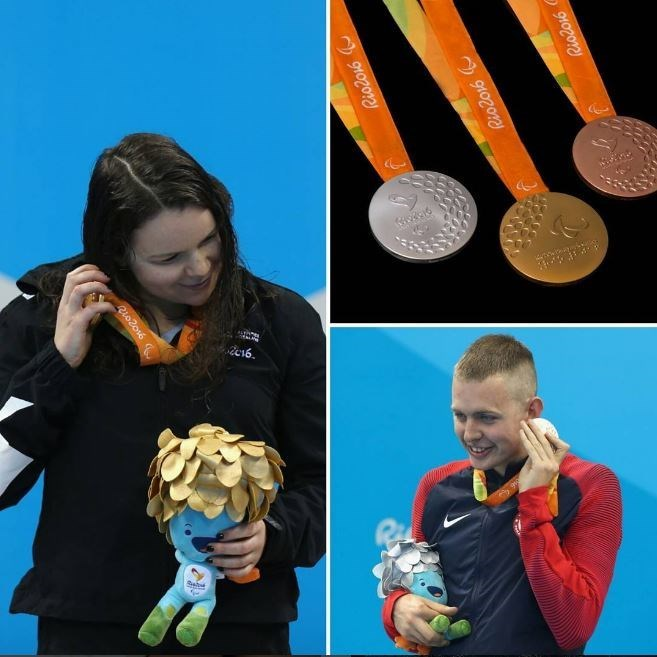How might the athletes' lives change after winning a silver medal at the Olympics? After winning a silver medal at the Olympics, the athletes' lives might change in several profound ways. They could receive increased media attention, which might open doors to sponsorships, endorsements, and speaking engagements. Their achievements could inspire new generations of athletes in their home countries, turning them into role models and heroes. Additionally, their professional careers could benefit as they now have Olympic credentials, potentially leading to more support and better opportunities to advance in their sport. On a personal level, the sense of accomplishment and recognition can contribute to heightened self-confidence and motivation to succeed in future competitions. 